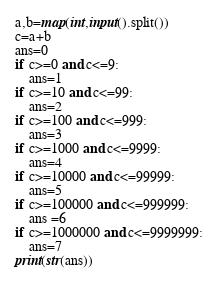Convert code to text. <code><loc_0><loc_0><loc_500><loc_500><_Python_>a,b=map(int,input().split())
c=a+b
ans=0
if c>=0 and c<=9:
    ans=1
if c>=10 and c<=99:
    ans=2
if c>=100 and c<=999:
    ans=3
if c>=1000 and c<=9999:
    ans=4
if c>=10000 and c<=99999:
    ans=5
if c>=100000 and c<=999999:
    ans =6
if c>=1000000 and c<=9999999:
    ans=7
print(str(ans))

</code> 